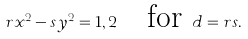<formula> <loc_0><loc_0><loc_500><loc_500>r x ^ { 2 } - s y ^ { 2 } = 1 , 2 \quad \text {for} \ d = r s .</formula> 